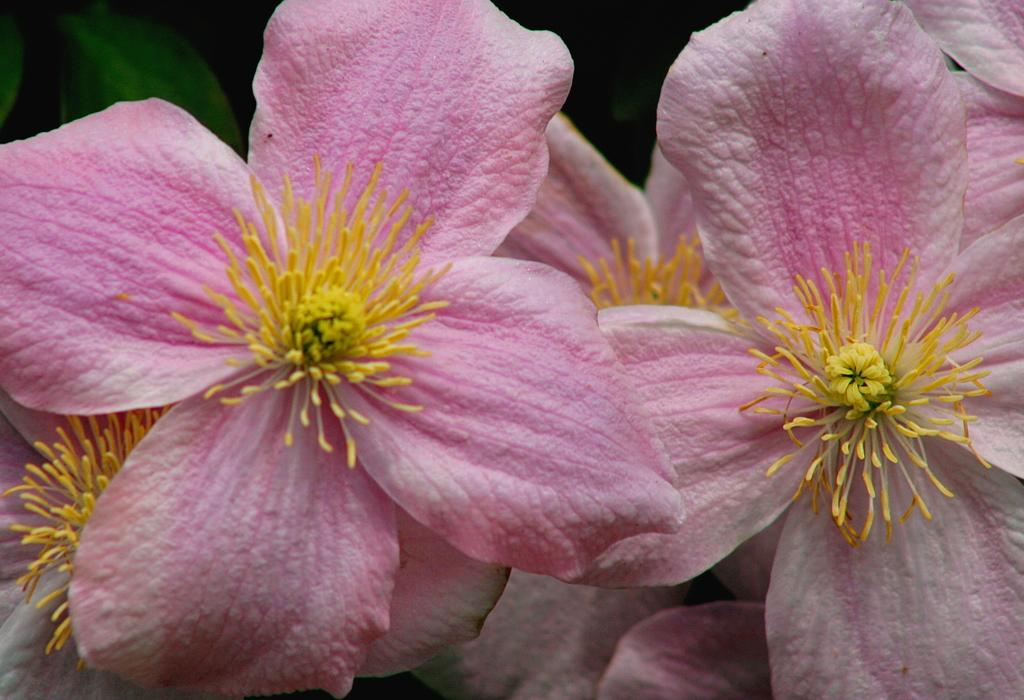What type of flora is present in the image? There are beautiful flowers in the image. What type of fan is visible in the image? There is no fan present in the image; it only features beautiful flowers. What season is depicted in the image? The image does not depict a specific season, as it only shows beautiful flowers. 